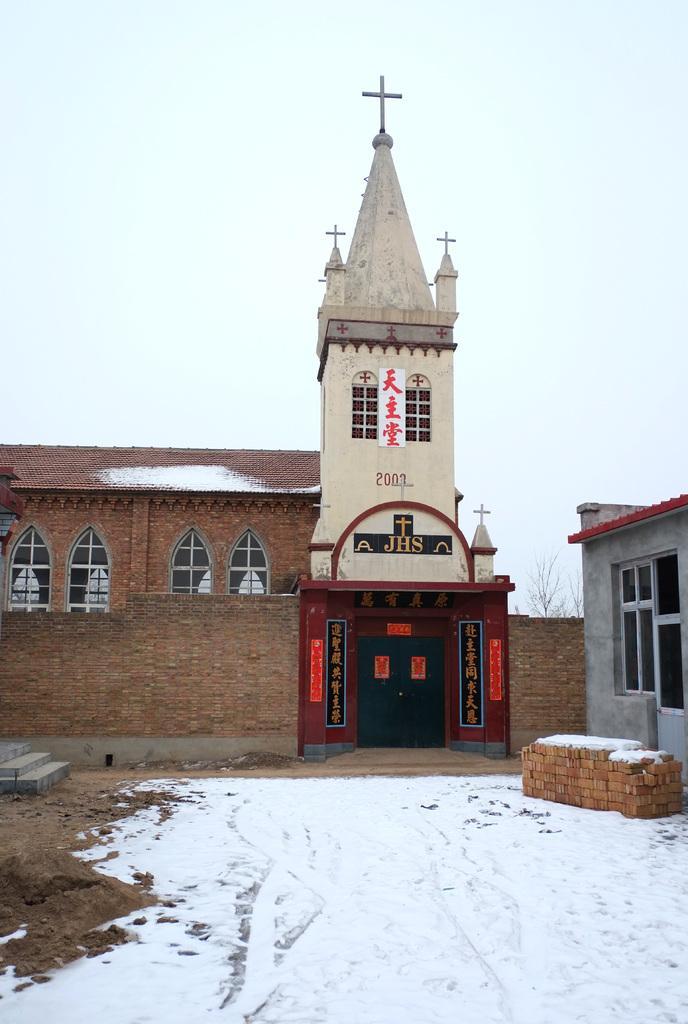How would you summarize this image in a sentence or two? I this image I can see snow, few buildings, a tree, the sky and here I can see something is written. I can also see few boards over here and on these boards I can see something is written. 